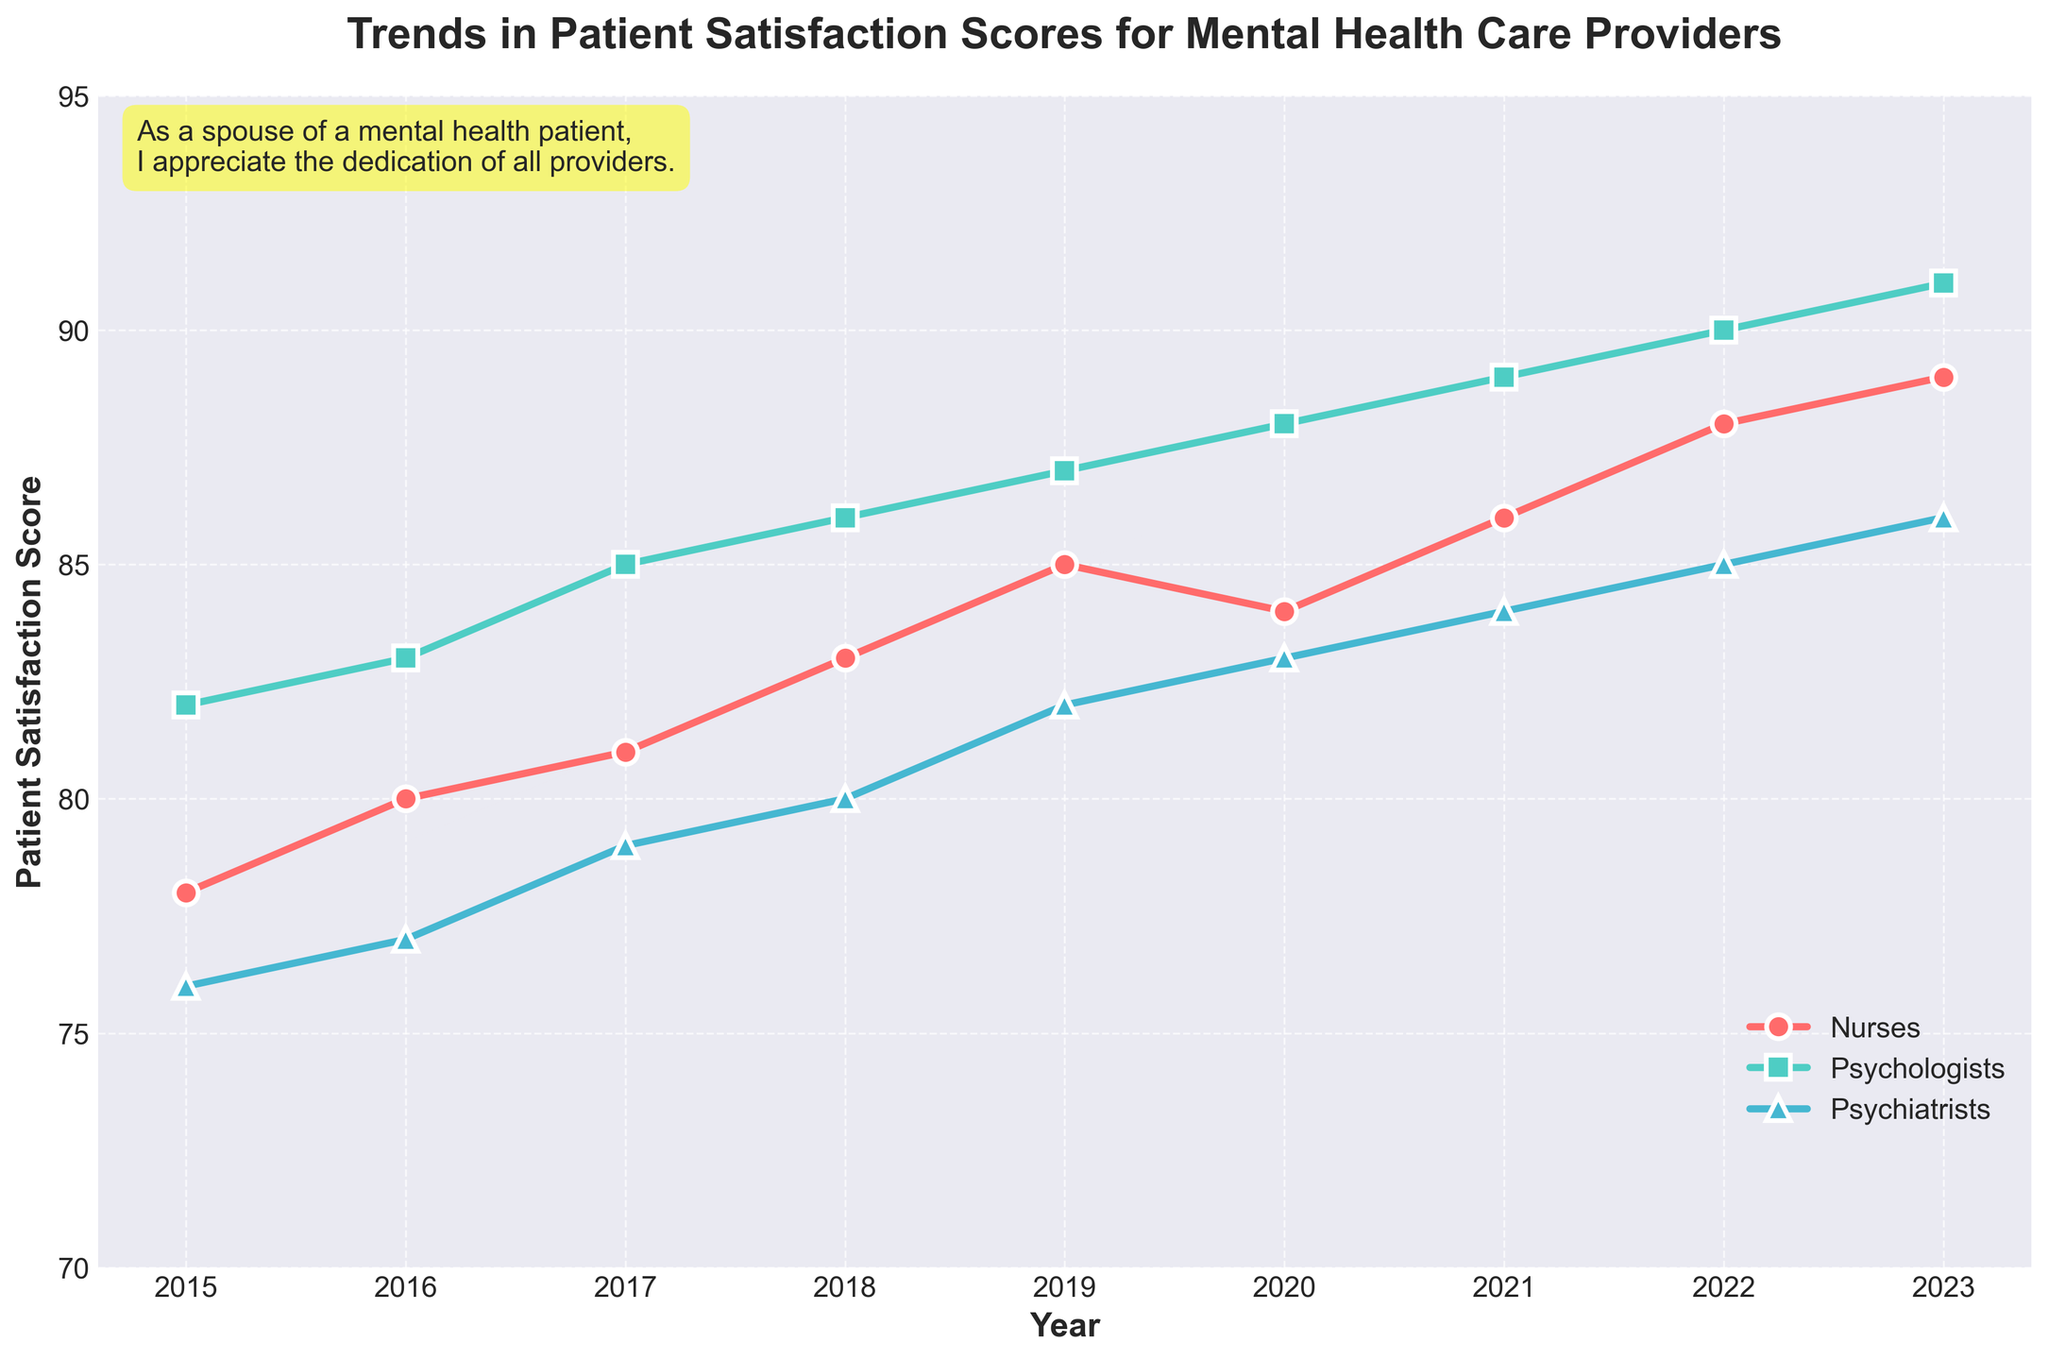What was the trend in patient satisfaction scores for nurses from 2015 to 2023? Look at the line representing nurses. It starts at 78 in 2015 and gradually increases over the years, reaching 89 in 2023.
Answer: Upward trend Which specialty had the highest patient satisfaction score in 2023? Compare the scores for nurses (89), psychologists (91), and psychiatrists (86) in 2023.
Answer: Psychologists By how many points did the satisfaction score of nurses increase from 2015 to 2023? Subtract the 2015 score (78) from the 2023 score (89). Calculation: 89 - 78 = 11
Answer: 11 points Between which consecutive years did psychologists see the highest increase in satisfaction scores? Compare the year-over-year differences: 
2015-2016: 1, 2016-2017: 2, 2017-2018: 1, 2018-2019: 1, 2019-2020: 1, 2020-2021: 1, 2021-2022: 1, 2022-2023: 1.
Answer: 2016-2017 Which year did psychiatrists have the lowest satisfaction score, and what was the score? Look for the lowest point on the psychiatrists' line, which is 76 in the year 2015.
Answer: 2015, 76 What is the average satisfaction score for psychologists from 2015 to 2023? Add the scores from 2015 (82) to 2023 (91) and divide by the number of years (9). Calculation: (82 + 83 + 85 + 86 + 87 + 88 + 89 + 90 + 91) / 9 = 87.4444
Answer: 87.44 In which year did nurses surpass a satisfaction score of 85 for the first time? Find the first year nurses' score exceeds 85, which is in 2019.
Answer: 2019 What is the difference in patient satisfaction scores between psychologists and psychiatrists in 2020? Subtract the 2020 score for psychiatrists (83) from the score for psychologists (88). Calculation: 88 - 83 = 5
Answer: 5 How did the satisfaction scores for psychiatrists change between 2017 and 2022? Look at the psychiatrists' scores for 2017 (79) and 2022 (85). The score increases by 6.
Answer: Increased by 6 Identify the specialty with the most consistent increase in satisfaction scores over the years. Examine the trends: Nurses (11-point increase), Psychologists (9-point increase), and Psychiatrists (10-point increase). All show consistent increases, but psychologists have the smallest fluctuations.
Answer: Psychologists 